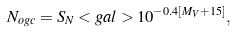Convert formula to latex. <formula><loc_0><loc_0><loc_500><loc_500>N _ { o g c } = S _ { N } < g a l > 1 0 ^ { - 0 . 4 [ M _ { V } + 1 5 ] } ,</formula> 